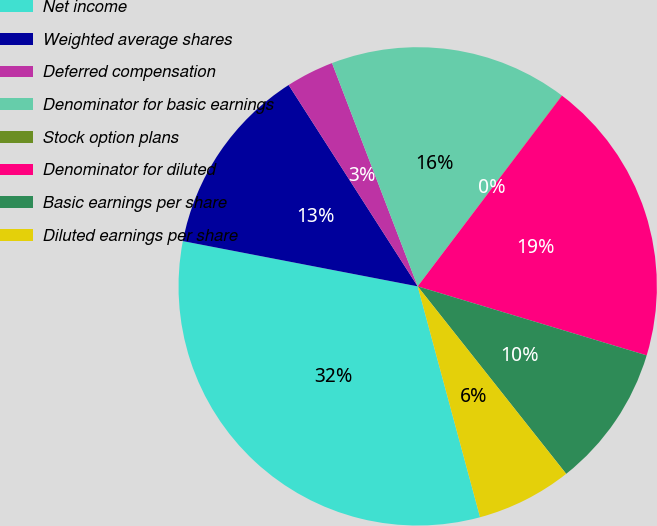<chart> <loc_0><loc_0><loc_500><loc_500><pie_chart><fcel>Net income<fcel>Weighted average shares<fcel>Deferred compensation<fcel>Denominator for basic earnings<fcel>Stock option plans<fcel>Denominator for diluted<fcel>Basic earnings per share<fcel>Diluted earnings per share<nl><fcel>32.23%<fcel>12.9%<fcel>3.24%<fcel>16.12%<fcel>0.02%<fcel>19.35%<fcel>9.68%<fcel>6.46%<nl></chart> 